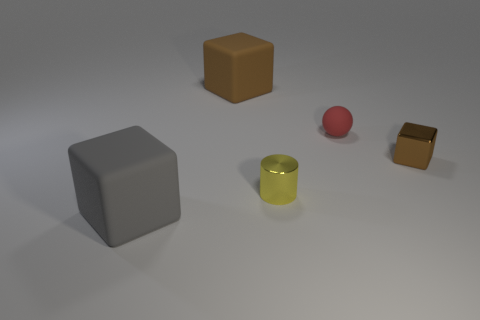Subtract all brown rubber cubes. How many cubes are left? 2 Subtract all brown blocks. How many blocks are left? 1 Subtract all blocks. How many objects are left? 2 Subtract 1 blocks. How many blocks are left? 2 Subtract all green spheres. Subtract all yellow blocks. How many spheres are left? 1 Subtract all red cylinders. How many cyan spheres are left? 0 Subtract all tiny green matte blocks. Subtract all brown matte blocks. How many objects are left? 4 Add 4 big matte blocks. How many big matte blocks are left? 6 Add 5 spheres. How many spheres exist? 6 Add 1 gray blocks. How many objects exist? 6 